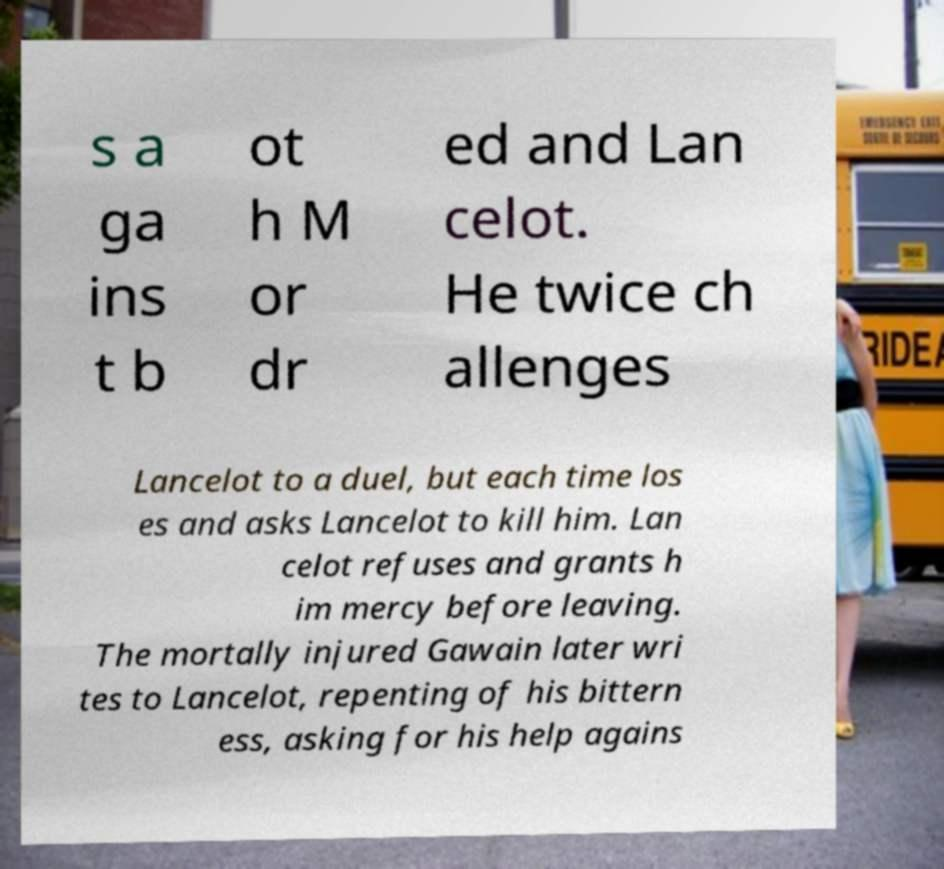Can you read and provide the text displayed in the image?This photo seems to have some interesting text. Can you extract and type it out for me? s a ga ins t b ot h M or dr ed and Lan celot. He twice ch allenges Lancelot to a duel, but each time los es and asks Lancelot to kill him. Lan celot refuses and grants h im mercy before leaving. The mortally injured Gawain later wri tes to Lancelot, repenting of his bittern ess, asking for his help agains 